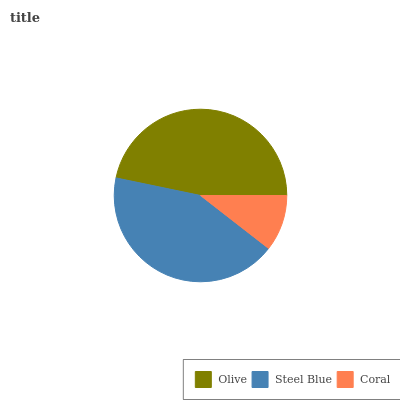Is Coral the minimum?
Answer yes or no. Yes. Is Olive the maximum?
Answer yes or no. Yes. Is Steel Blue the minimum?
Answer yes or no. No. Is Steel Blue the maximum?
Answer yes or no. No. Is Olive greater than Steel Blue?
Answer yes or no. Yes. Is Steel Blue less than Olive?
Answer yes or no. Yes. Is Steel Blue greater than Olive?
Answer yes or no. No. Is Olive less than Steel Blue?
Answer yes or no. No. Is Steel Blue the high median?
Answer yes or no. Yes. Is Steel Blue the low median?
Answer yes or no. Yes. Is Coral the high median?
Answer yes or no. No. Is Coral the low median?
Answer yes or no. No. 